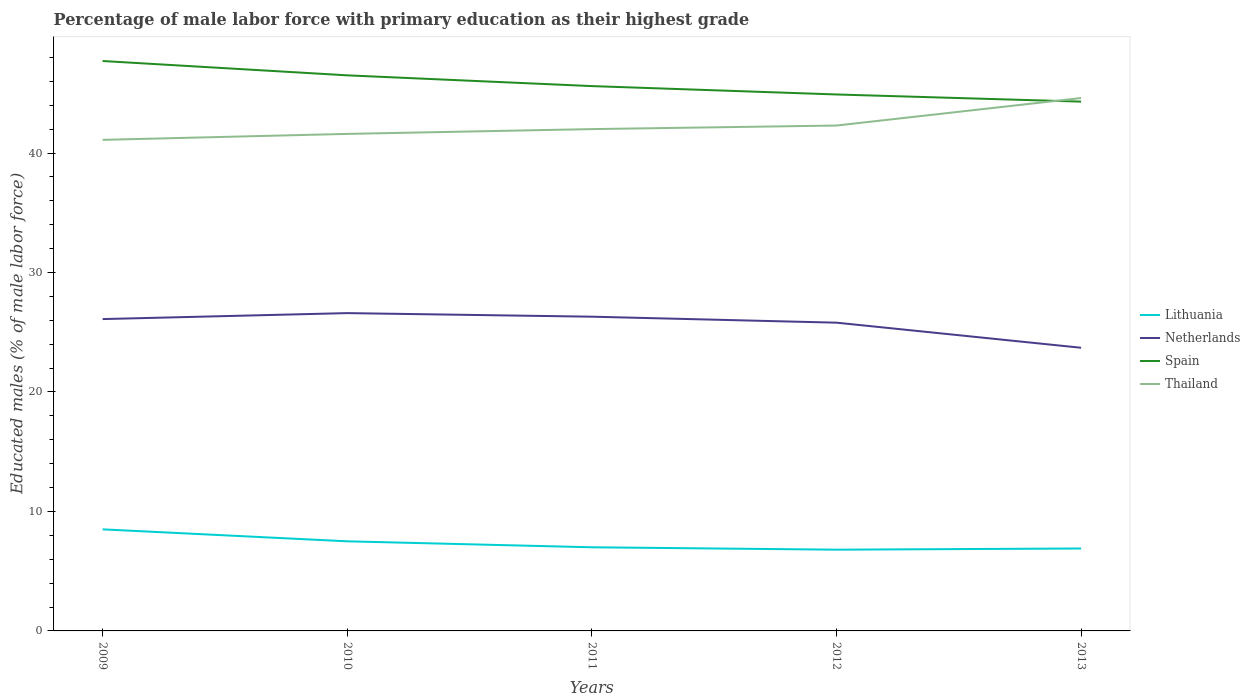Does the line corresponding to Spain intersect with the line corresponding to Netherlands?
Offer a terse response. No. Across all years, what is the maximum percentage of male labor force with primary education in Lithuania?
Give a very brief answer. 6.8. In which year was the percentage of male labor force with primary education in Netherlands maximum?
Give a very brief answer. 2013. What is the total percentage of male labor force with primary education in Netherlands in the graph?
Give a very brief answer. 2.6. What is the difference between the highest and the second highest percentage of male labor force with primary education in Lithuania?
Ensure brevity in your answer.  1.7. What is the difference between the highest and the lowest percentage of male labor force with primary education in Netherlands?
Your response must be concise. 4. Is the percentage of male labor force with primary education in Thailand strictly greater than the percentage of male labor force with primary education in Netherlands over the years?
Make the answer very short. No. What is the difference between two consecutive major ticks on the Y-axis?
Provide a short and direct response. 10. What is the title of the graph?
Provide a short and direct response. Percentage of male labor force with primary education as their highest grade. Does "Low income" appear as one of the legend labels in the graph?
Provide a succinct answer. No. What is the label or title of the X-axis?
Make the answer very short. Years. What is the label or title of the Y-axis?
Keep it short and to the point. Educated males (% of male labor force). What is the Educated males (% of male labor force) in Lithuania in 2009?
Your response must be concise. 8.5. What is the Educated males (% of male labor force) of Netherlands in 2009?
Make the answer very short. 26.1. What is the Educated males (% of male labor force) of Spain in 2009?
Offer a very short reply. 47.7. What is the Educated males (% of male labor force) in Thailand in 2009?
Give a very brief answer. 41.1. What is the Educated males (% of male labor force) in Netherlands in 2010?
Your answer should be very brief. 26.6. What is the Educated males (% of male labor force) of Spain in 2010?
Provide a succinct answer. 46.5. What is the Educated males (% of male labor force) of Thailand in 2010?
Keep it short and to the point. 41.6. What is the Educated males (% of male labor force) of Netherlands in 2011?
Your answer should be compact. 26.3. What is the Educated males (% of male labor force) of Spain in 2011?
Offer a terse response. 45.6. What is the Educated males (% of male labor force) of Thailand in 2011?
Make the answer very short. 42. What is the Educated males (% of male labor force) in Lithuania in 2012?
Give a very brief answer. 6.8. What is the Educated males (% of male labor force) in Netherlands in 2012?
Your answer should be very brief. 25.8. What is the Educated males (% of male labor force) of Spain in 2012?
Ensure brevity in your answer.  44.9. What is the Educated males (% of male labor force) of Thailand in 2012?
Offer a very short reply. 42.3. What is the Educated males (% of male labor force) in Lithuania in 2013?
Your response must be concise. 6.9. What is the Educated males (% of male labor force) of Netherlands in 2013?
Make the answer very short. 23.7. What is the Educated males (% of male labor force) of Spain in 2013?
Your answer should be compact. 44.3. What is the Educated males (% of male labor force) of Thailand in 2013?
Make the answer very short. 44.6. Across all years, what is the maximum Educated males (% of male labor force) in Lithuania?
Provide a short and direct response. 8.5. Across all years, what is the maximum Educated males (% of male labor force) of Netherlands?
Provide a succinct answer. 26.6. Across all years, what is the maximum Educated males (% of male labor force) in Spain?
Your response must be concise. 47.7. Across all years, what is the maximum Educated males (% of male labor force) of Thailand?
Offer a terse response. 44.6. Across all years, what is the minimum Educated males (% of male labor force) in Lithuania?
Your response must be concise. 6.8. Across all years, what is the minimum Educated males (% of male labor force) in Netherlands?
Your answer should be compact. 23.7. Across all years, what is the minimum Educated males (% of male labor force) in Spain?
Ensure brevity in your answer.  44.3. Across all years, what is the minimum Educated males (% of male labor force) of Thailand?
Your response must be concise. 41.1. What is the total Educated males (% of male labor force) in Lithuania in the graph?
Ensure brevity in your answer.  36.7. What is the total Educated males (% of male labor force) of Netherlands in the graph?
Provide a short and direct response. 128.5. What is the total Educated males (% of male labor force) in Spain in the graph?
Your response must be concise. 229. What is the total Educated males (% of male labor force) in Thailand in the graph?
Your answer should be compact. 211.6. What is the difference between the Educated males (% of male labor force) in Lithuania in 2009 and that in 2010?
Your answer should be very brief. 1. What is the difference between the Educated males (% of male labor force) of Spain in 2009 and that in 2010?
Your answer should be very brief. 1.2. What is the difference between the Educated males (% of male labor force) of Netherlands in 2009 and that in 2011?
Provide a short and direct response. -0.2. What is the difference between the Educated males (% of male labor force) in Netherlands in 2009 and that in 2012?
Provide a short and direct response. 0.3. What is the difference between the Educated males (% of male labor force) of Spain in 2009 and that in 2012?
Give a very brief answer. 2.8. What is the difference between the Educated males (% of male labor force) in Thailand in 2009 and that in 2012?
Offer a very short reply. -1.2. What is the difference between the Educated males (% of male labor force) in Netherlands in 2009 and that in 2013?
Your answer should be very brief. 2.4. What is the difference between the Educated males (% of male labor force) in Spain in 2009 and that in 2013?
Offer a very short reply. 3.4. What is the difference between the Educated males (% of male labor force) in Lithuania in 2010 and that in 2011?
Provide a short and direct response. 0.5. What is the difference between the Educated males (% of male labor force) of Spain in 2010 and that in 2011?
Offer a very short reply. 0.9. What is the difference between the Educated males (% of male labor force) in Lithuania in 2010 and that in 2013?
Your response must be concise. 0.6. What is the difference between the Educated males (% of male labor force) in Netherlands in 2010 and that in 2013?
Provide a short and direct response. 2.9. What is the difference between the Educated males (% of male labor force) in Spain in 2010 and that in 2013?
Your response must be concise. 2.2. What is the difference between the Educated males (% of male labor force) of Lithuania in 2011 and that in 2012?
Give a very brief answer. 0.2. What is the difference between the Educated males (% of male labor force) in Netherlands in 2011 and that in 2012?
Make the answer very short. 0.5. What is the difference between the Educated males (% of male labor force) in Thailand in 2011 and that in 2012?
Give a very brief answer. -0.3. What is the difference between the Educated males (% of male labor force) in Lithuania in 2011 and that in 2013?
Your answer should be very brief. 0.1. What is the difference between the Educated males (% of male labor force) in Netherlands in 2011 and that in 2013?
Give a very brief answer. 2.6. What is the difference between the Educated males (% of male labor force) in Spain in 2011 and that in 2013?
Offer a very short reply. 1.3. What is the difference between the Educated males (% of male labor force) in Thailand in 2011 and that in 2013?
Your answer should be compact. -2.6. What is the difference between the Educated males (% of male labor force) of Lithuania in 2012 and that in 2013?
Ensure brevity in your answer.  -0.1. What is the difference between the Educated males (% of male labor force) of Netherlands in 2012 and that in 2013?
Your answer should be very brief. 2.1. What is the difference between the Educated males (% of male labor force) in Lithuania in 2009 and the Educated males (% of male labor force) in Netherlands in 2010?
Your answer should be very brief. -18.1. What is the difference between the Educated males (% of male labor force) of Lithuania in 2009 and the Educated males (% of male labor force) of Spain in 2010?
Provide a succinct answer. -38. What is the difference between the Educated males (% of male labor force) in Lithuania in 2009 and the Educated males (% of male labor force) in Thailand in 2010?
Provide a succinct answer. -33.1. What is the difference between the Educated males (% of male labor force) of Netherlands in 2009 and the Educated males (% of male labor force) of Spain in 2010?
Make the answer very short. -20.4. What is the difference between the Educated males (% of male labor force) of Netherlands in 2009 and the Educated males (% of male labor force) of Thailand in 2010?
Make the answer very short. -15.5. What is the difference between the Educated males (% of male labor force) in Lithuania in 2009 and the Educated males (% of male labor force) in Netherlands in 2011?
Keep it short and to the point. -17.8. What is the difference between the Educated males (% of male labor force) in Lithuania in 2009 and the Educated males (% of male labor force) in Spain in 2011?
Make the answer very short. -37.1. What is the difference between the Educated males (% of male labor force) of Lithuania in 2009 and the Educated males (% of male labor force) of Thailand in 2011?
Keep it short and to the point. -33.5. What is the difference between the Educated males (% of male labor force) in Netherlands in 2009 and the Educated males (% of male labor force) in Spain in 2011?
Your answer should be compact. -19.5. What is the difference between the Educated males (% of male labor force) of Netherlands in 2009 and the Educated males (% of male labor force) of Thailand in 2011?
Provide a short and direct response. -15.9. What is the difference between the Educated males (% of male labor force) of Lithuania in 2009 and the Educated males (% of male labor force) of Netherlands in 2012?
Your response must be concise. -17.3. What is the difference between the Educated males (% of male labor force) in Lithuania in 2009 and the Educated males (% of male labor force) in Spain in 2012?
Make the answer very short. -36.4. What is the difference between the Educated males (% of male labor force) in Lithuania in 2009 and the Educated males (% of male labor force) in Thailand in 2012?
Your answer should be compact. -33.8. What is the difference between the Educated males (% of male labor force) of Netherlands in 2009 and the Educated males (% of male labor force) of Spain in 2012?
Offer a terse response. -18.8. What is the difference between the Educated males (% of male labor force) of Netherlands in 2009 and the Educated males (% of male labor force) of Thailand in 2012?
Give a very brief answer. -16.2. What is the difference between the Educated males (% of male labor force) in Spain in 2009 and the Educated males (% of male labor force) in Thailand in 2012?
Make the answer very short. 5.4. What is the difference between the Educated males (% of male labor force) of Lithuania in 2009 and the Educated males (% of male labor force) of Netherlands in 2013?
Provide a succinct answer. -15.2. What is the difference between the Educated males (% of male labor force) in Lithuania in 2009 and the Educated males (% of male labor force) in Spain in 2013?
Your answer should be compact. -35.8. What is the difference between the Educated males (% of male labor force) in Lithuania in 2009 and the Educated males (% of male labor force) in Thailand in 2013?
Ensure brevity in your answer.  -36.1. What is the difference between the Educated males (% of male labor force) of Netherlands in 2009 and the Educated males (% of male labor force) of Spain in 2013?
Make the answer very short. -18.2. What is the difference between the Educated males (% of male labor force) in Netherlands in 2009 and the Educated males (% of male labor force) in Thailand in 2013?
Give a very brief answer. -18.5. What is the difference between the Educated males (% of male labor force) of Spain in 2009 and the Educated males (% of male labor force) of Thailand in 2013?
Provide a short and direct response. 3.1. What is the difference between the Educated males (% of male labor force) in Lithuania in 2010 and the Educated males (% of male labor force) in Netherlands in 2011?
Offer a terse response. -18.8. What is the difference between the Educated males (% of male labor force) in Lithuania in 2010 and the Educated males (% of male labor force) in Spain in 2011?
Your answer should be compact. -38.1. What is the difference between the Educated males (% of male labor force) in Lithuania in 2010 and the Educated males (% of male labor force) in Thailand in 2011?
Your answer should be very brief. -34.5. What is the difference between the Educated males (% of male labor force) of Netherlands in 2010 and the Educated males (% of male labor force) of Thailand in 2011?
Make the answer very short. -15.4. What is the difference between the Educated males (% of male labor force) of Spain in 2010 and the Educated males (% of male labor force) of Thailand in 2011?
Your answer should be very brief. 4.5. What is the difference between the Educated males (% of male labor force) of Lithuania in 2010 and the Educated males (% of male labor force) of Netherlands in 2012?
Your answer should be compact. -18.3. What is the difference between the Educated males (% of male labor force) of Lithuania in 2010 and the Educated males (% of male labor force) of Spain in 2012?
Provide a short and direct response. -37.4. What is the difference between the Educated males (% of male labor force) in Lithuania in 2010 and the Educated males (% of male labor force) in Thailand in 2012?
Give a very brief answer. -34.8. What is the difference between the Educated males (% of male labor force) in Netherlands in 2010 and the Educated males (% of male labor force) in Spain in 2012?
Ensure brevity in your answer.  -18.3. What is the difference between the Educated males (% of male labor force) in Netherlands in 2010 and the Educated males (% of male labor force) in Thailand in 2012?
Offer a very short reply. -15.7. What is the difference between the Educated males (% of male labor force) in Spain in 2010 and the Educated males (% of male labor force) in Thailand in 2012?
Offer a very short reply. 4.2. What is the difference between the Educated males (% of male labor force) in Lithuania in 2010 and the Educated males (% of male labor force) in Netherlands in 2013?
Your response must be concise. -16.2. What is the difference between the Educated males (% of male labor force) of Lithuania in 2010 and the Educated males (% of male labor force) of Spain in 2013?
Ensure brevity in your answer.  -36.8. What is the difference between the Educated males (% of male labor force) in Lithuania in 2010 and the Educated males (% of male labor force) in Thailand in 2013?
Offer a very short reply. -37.1. What is the difference between the Educated males (% of male labor force) in Netherlands in 2010 and the Educated males (% of male labor force) in Spain in 2013?
Give a very brief answer. -17.7. What is the difference between the Educated males (% of male labor force) in Netherlands in 2010 and the Educated males (% of male labor force) in Thailand in 2013?
Offer a terse response. -18. What is the difference between the Educated males (% of male labor force) of Lithuania in 2011 and the Educated males (% of male labor force) of Netherlands in 2012?
Provide a short and direct response. -18.8. What is the difference between the Educated males (% of male labor force) in Lithuania in 2011 and the Educated males (% of male labor force) in Spain in 2012?
Make the answer very short. -37.9. What is the difference between the Educated males (% of male labor force) in Lithuania in 2011 and the Educated males (% of male labor force) in Thailand in 2012?
Give a very brief answer. -35.3. What is the difference between the Educated males (% of male labor force) of Netherlands in 2011 and the Educated males (% of male labor force) of Spain in 2012?
Your answer should be compact. -18.6. What is the difference between the Educated males (% of male labor force) in Netherlands in 2011 and the Educated males (% of male labor force) in Thailand in 2012?
Make the answer very short. -16. What is the difference between the Educated males (% of male labor force) in Lithuania in 2011 and the Educated males (% of male labor force) in Netherlands in 2013?
Offer a very short reply. -16.7. What is the difference between the Educated males (% of male labor force) of Lithuania in 2011 and the Educated males (% of male labor force) of Spain in 2013?
Offer a very short reply. -37.3. What is the difference between the Educated males (% of male labor force) of Lithuania in 2011 and the Educated males (% of male labor force) of Thailand in 2013?
Offer a very short reply. -37.6. What is the difference between the Educated males (% of male labor force) of Netherlands in 2011 and the Educated males (% of male labor force) of Spain in 2013?
Ensure brevity in your answer.  -18. What is the difference between the Educated males (% of male labor force) of Netherlands in 2011 and the Educated males (% of male labor force) of Thailand in 2013?
Your response must be concise. -18.3. What is the difference between the Educated males (% of male labor force) of Lithuania in 2012 and the Educated males (% of male labor force) of Netherlands in 2013?
Provide a short and direct response. -16.9. What is the difference between the Educated males (% of male labor force) in Lithuania in 2012 and the Educated males (% of male labor force) in Spain in 2013?
Give a very brief answer. -37.5. What is the difference between the Educated males (% of male labor force) of Lithuania in 2012 and the Educated males (% of male labor force) of Thailand in 2013?
Your response must be concise. -37.8. What is the difference between the Educated males (% of male labor force) in Netherlands in 2012 and the Educated males (% of male labor force) in Spain in 2013?
Provide a short and direct response. -18.5. What is the difference between the Educated males (% of male labor force) in Netherlands in 2012 and the Educated males (% of male labor force) in Thailand in 2013?
Your response must be concise. -18.8. What is the average Educated males (% of male labor force) of Lithuania per year?
Offer a terse response. 7.34. What is the average Educated males (% of male labor force) of Netherlands per year?
Offer a terse response. 25.7. What is the average Educated males (% of male labor force) in Spain per year?
Provide a succinct answer. 45.8. What is the average Educated males (% of male labor force) in Thailand per year?
Your answer should be compact. 42.32. In the year 2009, what is the difference between the Educated males (% of male labor force) in Lithuania and Educated males (% of male labor force) in Netherlands?
Your answer should be compact. -17.6. In the year 2009, what is the difference between the Educated males (% of male labor force) in Lithuania and Educated males (% of male labor force) in Spain?
Offer a terse response. -39.2. In the year 2009, what is the difference between the Educated males (% of male labor force) of Lithuania and Educated males (% of male labor force) of Thailand?
Provide a succinct answer. -32.6. In the year 2009, what is the difference between the Educated males (% of male labor force) in Netherlands and Educated males (% of male labor force) in Spain?
Your answer should be very brief. -21.6. In the year 2009, what is the difference between the Educated males (% of male labor force) in Netherlands and Educated males (% of male labor force) in Thailand?
Keep it short and to the point. -15. In the year 2009, what is the difference between the Educated males (% of male labor force) in Spain and Educated males (% of male labor force) in Thailand?
Ensure brevity in your answer.  6.6. In the year 2010, what is the difference between the Educated males (% of male labor force) in Lithuania and Educated males (% of male labor force) in Netherlands?
Keep it short and to the point. -19.1. In the year 2010, what is the difference between the Educated males (% of male labor force) of Lithuania and Educated males (% of male labor force) of Spain?
Ensure brevity in your answer.  -39. In the year 2010, what is the difference between the Educated males (% of male labor force) in Lithuania and Educated males (% of male labor force) in Thailand?
Your response must be concise. -34.1. In the year 2010, what is the difference between the Educated males (% of male labor force) of Netherlands and Educated males (% of male labor force) of Spain?
Offer a terse response. -19.9. In the year 2010, what is the difference between the Educated males (% of male labor force) of Spain and Educated males (% of male labor force) of Thailand?
Make the answer very short. 4.9. In the year 2011, what is the difference between the Educated males (% of male labor force) of Lithuania and Educated males (% of male labor force) of Netherlands?
Provide a short and direct response. -19.3. In the year 2011, what is the difference between the Educated males (% of male labor force) in Lithuania and Educated males (% of male labor force) in Spain?
Make the answer very short. -38.6. In the year 2011, what is the difference between the Educated males (% of male labor force) of Lithuania and Educated males (% of male labor force) of Thailand?
Give a very brief answer. -35. In the year 2011, what is the difference between the Educated males (% of male labor force) in Netherlands and Educated males (% of male labor force) in Spain?
Ensure brevity in your answer.  -19.3. In the year 2011, what is the difference between the Educated males (% of male labor force) in Netherlands and Educated males (% of male labor force) in Thailand?
Make the answer very short. -15.7. In the year 2012, what is the difference between the Educated males (% of male labor force) in Lithuania and Educated males (% of male labor force) in Spain?
Offer a terse response. -38.1. In the year 2012, what is the difference between the Educated males (% of male labor force) in Lithuania and Educated males (% of male labor force) in Thailand?
Your answer should be very brief. -35.5. In the year 2012, what is the difference between the Educated males (% of male labor force) of Netherlands and Educated males (% of male labor force) of Spain?
Provide a succinct answer. -19.1. In the year 2012, what is the difference between the Educated males (% of male labor force) of Netherlands and Educated males (% of male labor force) of Thailand?
Your answer should be compact. -16.5. In the year 2012, what is the difference between the Educated males (% of male labor force) of Spain and Educated males (% of male labor force) of Thailand?
Give a very brief answer. 2.6. In the year 2013, what is the difference between the Educated males (% of male labor force) of Lithuania and Educated males (% of male labor force) of Netherlands?
Your answer should be compact. -16.8. In the year 2013, what is the difference between the Educated males (% of male labor force) of Lithuania and Educated males (% of male labor force) of Spain?
Your answer should be compact. -37.4. In the year 2013, what is the difference between the Educated males (% of male labor force) in Lithuania and Educated males (% of male labor force) in Thailand?
Provide a succinct answer. -37.7. In the year 2013, what is the difference between the Educated males (% of male labor force) in Netherlands and Educated males (% of male labor force) in Spain?
Provide a succinct answer. -20.6. In the year 2013, what is the difference between the Educated males (% of male labor force) in Netherlands and Educated males (% of male labor force) in Thailand?
Offer a very short reply. -20.9. In the year 2013, what is the difference between the Educated males (% of male labor force) of Spain and Educated males (% of male labor force) of Thailand?
Keep it short and to the point. -0.3. What is the ratio of the Educated males (% of male labor force) of Lithuania in 2009 to that in 2010?
Provide a succinct answer. 1.13. What is the ratio of the Educated males (% of male labor force) in Netherlands in 2009 to that in 2010?
Keep it short and to the point. 0.98. What is the ratio of the Educated males (% of male labor force) of Spain in 2009 to that in 2010?
Make the answer very short. 1.03. What is the ratio of the Educated males (% of male labor force) in Thailand in 2009 to that in 2010?
Your answer should be compact. 0.99. What is the ratio of the Educated males (% of male labor force) of Lithuania in 2009 to that in 2011?
Keep it short and to the point. 1.21. What is the ratio of the Educated males (% of male labor force) in Spain in 2009 to that in 2011?
Keep it short and to the point. 1.05. What is the ratio of the Educated males (% of male labor force) in Thailand in 2009 to that in 2011?
Offer a terse response. 0.98. What is the ratio of the Educated males (% of male labor force) of Netherlands in 2009 to that in 2012?
Make the answer very short. 1.01. What is the ratio of the Educated males (% of male labor force) of Spain in 2009 to that in 2012?
Make the answer very short. 1.06. What is the ratio of the Educated males (% of male labor force) of Thailand in 2009 to that in 2012?
Ensure brevity in your answer.  0.97. What is the ratio of the Educated males (% of male labor force) in Lithuania in 2009 to that in 2013?
Ensure brevity in your answer.  1.23. What is the ratio of the Educated males (% of male labor force) of Netherlands in 2009 to that in 2013?
Provide a short and direct response. 1.1. What is the ratio of the Educated males (% of male labor force) in Spain in 2009 to that in 2013?
Provide a short and direct response. 1.08. What is the ratio of the Educated males (% of male labor force) of Thailand in 2009 to that in 2013?
Provide a short and direct response. 0.92. What is the ratio of the Educated males (% of male labor force) of Lithuania in 2010 to that in 2011?
Offer a terse response. 1.07. What is the ratio of the Educated males (% of male labor force) in Netherlands in 2010 to that in 2011?
Provide a short and direct response. 1.01. What is the ratio of the Educated males (% of male labor force) in Spain in 2010 to that in 2011?
Your answer should be compact. 1.02. What is the ratio of the Educated males (% of male labor force) in Lithuania in 2010 to that in 2012?
Ensure brevity in your answer.  1.1. What is the ratio of the Educated males (% of male labor force) in Netherlands in 2010 to that in 2012?
Offer a very short reply. 1.03. What is the ratio of the Educated males (% of male labor force) in Spain in 2010 to that in 2012?
Offer a very short reply. 1.04. What is the ratio of the Educated males (% of male labor force) in Thailand in 2010 to that in 2012?
Your answer should be compact. 0.98. What is the ratio of the Educated males (% of male labor force) in Lithuania in 2010 to that in 2013?
Your answer should be compact. 1.09. What is the ratio of the Educated males (% of male labor force) in Netherlands in 2010 to that in 2013?
Your answer should be very brief. 1.12. What is the ratio of the Educated males (% of male labor force) in Spain in 2010 to that in 2013?
Make the answer very short. 1.05. What is the ratio of the Educated males (% of male labor force) in Thailand in 2010 to that in 2013?
Your answer should be very brief. 0.93. What is the ratio of the Educated males (% of male labor force) in Lithuania in 2011 to that in 2012?
Make the answer very short. 1.03. What is the ratio of the Educated males (% of male labor force) in Netherlands in 2011 to that in 2012?
Make the answer very short. 1.02. What is the ratio of the Educated males (% of male labor force) in Spain in 2011 to that in 2012?
Your response must be concise. 1.02. What is the ratio of the Educated males (% of male labor force) of Thailand in 2011 to that in 2012?
Provide a short and direct response. 0.99. What is the ratio of the Educated males (% of male labor force) of Lithuania in 2011 to that in 2013?
Make the answer very short. 1.01. What is the ratio of the Educated males (% of male labor force) in Netherlands in 2011 to that in 2013?
Make the answer very short. 1.11. What is the ratio of the Educated males (% of male labor force) in Spain in 2011 to that in 2013?
Your answer should be very brief. 1.03. What is the ratio of the Educated males (% of male labor force) of Thailand in 2011 to that in 2013?
Offer a terse response. 0.94. What is the ratio of the Educated males (% of male labor force) in Lithuania in 2012 to that in 2013?
Your answer should be compact. 0.99. What is the ratio of the Educated males (% of male labor force) of Netherlands in 2012 to that in 2013?
Offer a very short reply. 1.09. What is the ratio of the Educated males (% of male labor force) in Spain in 2012 to that in 2013?
Ensure brevity in your answer.  1.01. What is the ratio of the Educated males (% of male labor force) of Thailand in 2012 to that in 2013?
Ensure brevity in your answer.  0.95. What is the difference between the highest and the second highest Educated males (% of male labor force) in Lithuania?
Make the answer very short. 1. What is the difference between the highest and the lowest Educated males (% of male labor force) of Lithuania?
Offer a very short reply. 1.7. What is the difference between the highest and the lowest Educated males (% of male labor force) of Netherlands?
Provide a succinct answer. 2.9. What is the difference between the highest and the lowest Educated males (% of male labor force) of Spain?
Provide a short and direct response. 3.4. 